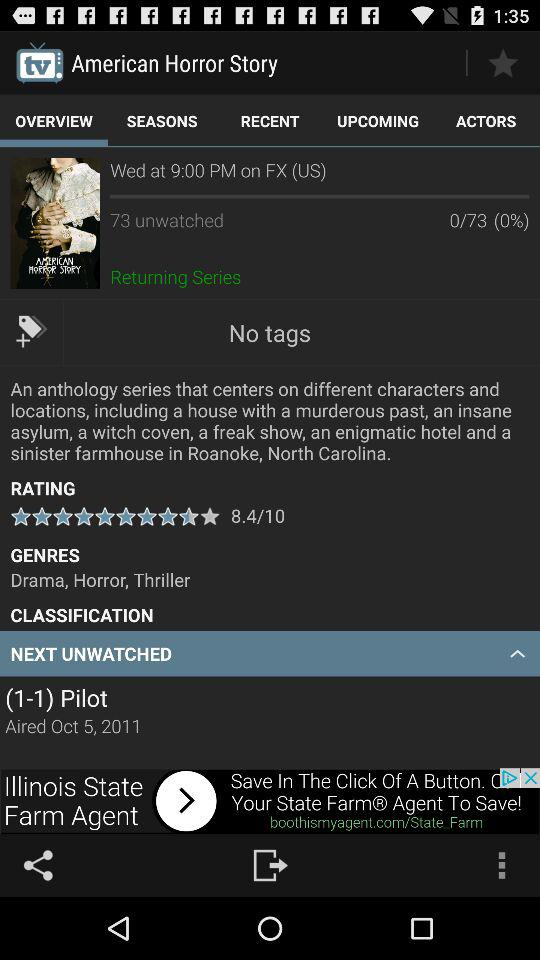Which tab is selected? The selected tab is "OVERVIEW". 